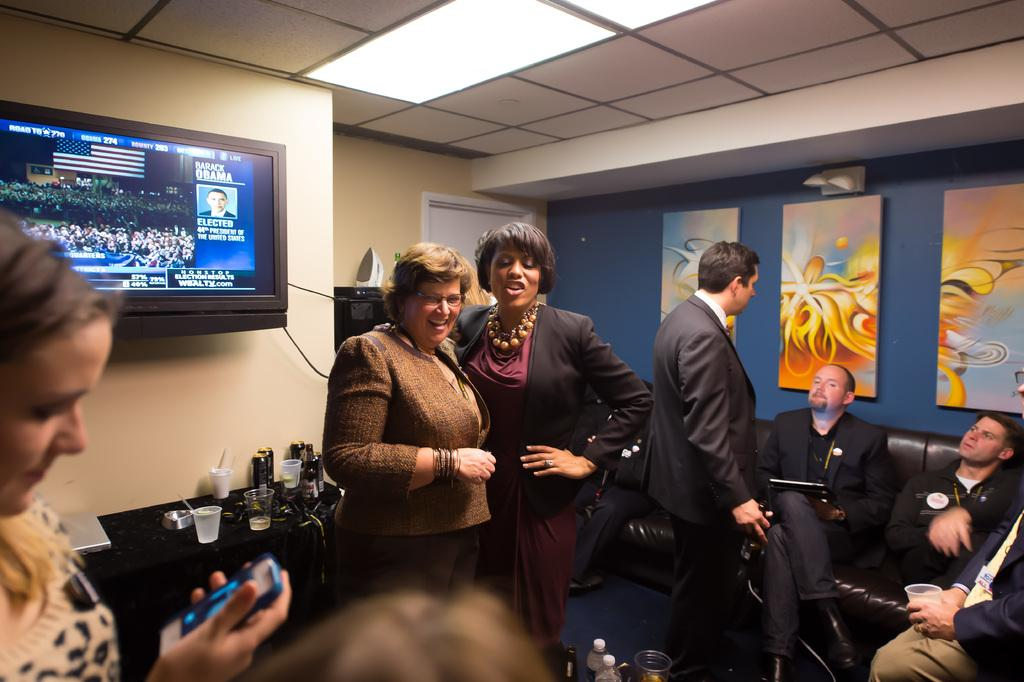What are the people in the image doing? There are people sitting on the sofa in the image. What can be seen on the wall in the image? There are portraits and a TV on the wall in the image. What objects are on the table in the image? There are glasses on the table in the image. What type of fork can be seen in the image? There is no fork present in the image. What process is being carried out by the people sitting on the sofa? The image does not provide enough information to determine any specific process being carried out by the people sitting on the sofa. 